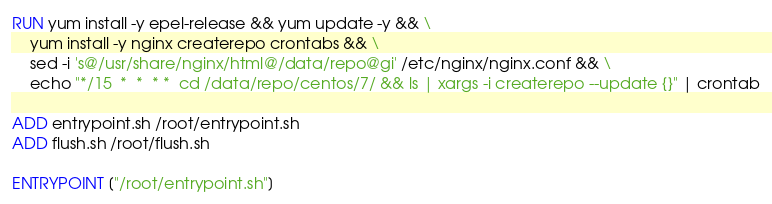Convert code to text. <code><loc_0><loc_0><loc_500><loc_500><_Dockerfile_>
RUN yum install -y epel-release && yum update -y && \
    yum install -y nginx createrepo crontabs && \
    sed -i 's@/usr/share/nginx/html@/data/repo@gi' /etc/nginx/nginx.conf && \
    echo "*/15  *  *  * *  cd /data/repo/centos/7/ && ls | xargs -i createrepo --update {}" | crontab

ADD entrypoint.sh /root/entrypoint.sh
ADD flush.sh /root/flush.sh

ENTRYPOINT ["/root/entrypoint.sh"]
</code> 